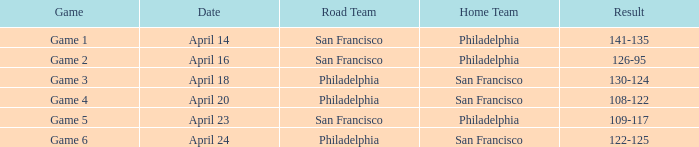Which game had Philadelphia as its home team and was played on April 23? Game 5. 